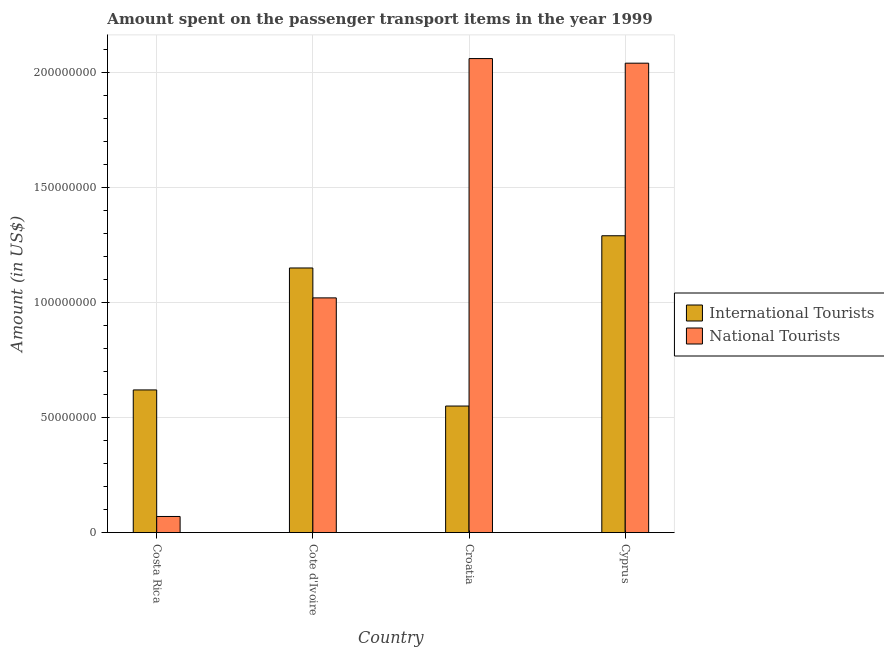How many bars are there on the 1st tick from the left?
Offer a terse response. 2. How many bars are there on the 2nd tick from the right?
Your answer should be very brief. 2. What is the label of the 2nd group of bars from the left?
Provide a short and direct response. Cote d'Ivoire. What is the amount spent on transport items of international tourists in Croatia?
Offer a terse response. 5.50e+07. Across all countries, what is the maximum amount spent on transport items of national tourists?
Your response must be concise. 2.06e+08. Across all countries, what is the minimum amount spent on transport items of national tourists?
Give a very brief answer. 7.00e+06. In which country was the amount spent on transport items of national tourists maximum?
Your answer should be compact. Croatia. In which country was the amount spent on transport items of national tourists minimum?
Your answer should be compact. Costa Rica. What is the total amount spent on transport items of national tourists in the graph?
Offer a terse response. 5.19e+08. What is the difference between the amount spent on transport items of international tourists in Cote d'Ivoire and that in Croatia?
Your answer should be very brief. 6.00e+07. What is the difference between the amount spent on transport items of national tourists in Costa Rica and the amount spent on transport items of international tourists in Cote d'Ivoire?
Provide a succinct answer. -1.08e+08. What is the average amount spent on transport items of international tourists per country?
Make the answer very short. 9.02e+07. What is the difference between the amount spent on transport items of international tourists and amount spent on transport items of national tourists in Cote d'Ivoire?
Make the answer very short. 1.30e+07. What is the ratio of the amount spent on transport items of national tourists in Costa Rica to that in Cyprus?
Offer a very short reply. 0.03. Is the difference between the amount spent on transport items of international tourists in Croatia and Cyprus greater than the difference between the amount spent on transport items of national tourists in Croatia and Cyprus?
Your response must be concise. No. What is the difference between the highest and the second highest amount spent on transport items of international tourists?
Your answer should be compact. 1.40e+07. What is the difference between the highest and the lowest amount spent on transport items of international tourists?
Give a very brief answer. 7.40e+07. In how many countries, is the amount spent on transport items of national tourists greater than the average amount spent on transport items of national tourists taken over all countries?
Your answer should be compact. 2. Is the sum of the amount spent on transport items of national tourists in Costa Rica and Croatia greater than the maximum amount spent on transport items of international tourists across all countries?
Offer a terse response. Yes. What does the 1st bar from the left in Croatia represents?
Your answer should be compact. International Tourists. What does the 1st bar from the right in Cote d'Ivoire represents?
Offer a very short reply. National Tourists. Are all the bars in the graph horizontal?
Give a very brief answer. No. What is the difference between two consecutive major ticks on the Y-axis?
Offer a terse response. 5.00e+07. Are the values on the major ticks of Y-axis written in scientific E-notation?
Make the answer very short. No. What is the title of the graph?
Your answer should be compact. Amount spent on the passenger transport items in the year 1999. What is the Amount (in US$) in International Tourists in Costa Rica?
Offer a very short reply. 6.20e+07. What is the Amount (in US$) of National Tourists in Costa Rica?
Your response must be concise. 7.00e+06. What is the Amount (in US$) in International Tourists in Cote d'Ivoire?
Make the answer very short. 1.15e+08. What is the Amount (in US$) of National Tourists in Cote d'Ivoire?
Offer a very short reply. 1.02e+08. What is the Amount (in US$) of International Tourists in Croatia?
Provide a succinct answer. 5.50e+07. What is the Amount (in US$) in National Tourists in Croatia?
Give a very brief answer. 2.06e+08. What is the Amount (in US$) in International Tourists in Cyprus?
Provide a short and direct response. 1.29e+08. What is the Amount (in US$) of National Tourists in Cyprus?
Your answer should be compact. 2.04e+08. Across all countries, what is the maximum Amount (in US$) in International Tourists?
Your answer should be compact. 1.29e+08. Across all countries, what is the maximum Amount (in US$) in National Tourists?
Give a very brief answer. 2.06e+08. Across all countries, what is the minimum Amount (in US$) of International Tourists?
Keep it short and to the point. 5.50e+07. What is the total Amount (in US$) in International Tourists in the graph?
Offer a terse response. 3.61e+08. What is the total Amount (in US$) in National Tourists in the graph?
Give a very brief answer. 5.19e+08. What is the difference between the Amount (in US$) in International Tourists in Costa Rica and that in Cote d'Ivoire?
Offer a terse response. -5.30e+07. What is the difference between the Amount (in US$) of National Tourists in Costa Rica and that in Cote d'Ivoire?
Your response must be concise. -9.50e+07. What is the difference between the Amount (in US$) of International Tourists in Costa Rica and that in Croatia?
Ensure brevity in your answer.  7.00e+06. What is the difference between the Amount (in US$) in National Tourists in Costa Rica and that in Croatia?
Make the answer very short. -1.99e+08. What is the difference between the Amount (in US$) of International Tourists in Costa Rica and that in Cyprus?
Provide a short and direct response. -6.70e+07. What is the difference between the Amount (in US$) of National Tourists in Costa Rica and that in Cyprus?
Give a very brief answer. -1.97e+08. What is the difference between the Amount (in US$) in International Tourists in Cote d'Ivoire and that in Croatia?
Ensure brevity in your answer.  6.00e+07. What is the difference between the Amount (in US$) of National Tourists in Cote d'Ivoire and that in Croatia?
Give a very brief answer. -1.04e+08. What is the difference between the Amount (in US$) of International Tourists in Cote d'Ivoire and that in Cyprus?
Provide a succinct answer. -1.40e+07. What is the difference between the Amount (in US$) of National Tourists in Cote d'Ivoire and that in Cyprus?
Keep it short and to the point. -1.02e+08. What is the difference between the Amount (in US$) in International Tourists in Croatia and that in Cyprus?
Provide a succinct answer. -7.40e+07. What is the difference between the Amount (in US$) in International Tourists in Costa Rica and the Amount (in US$) in National Tourists in Cote d'Ivoire?
Provide a succinct answer. -4.00e+07. What is the difference between the Amount (in US$) of International Tourists in Costa Rica and the Amount (in US$) of National Tourists in Croatia?
Offer a terse response. -1.44e+08. What is the difference between the Amount (in US$) of International Tourists in Costa Rica and the Amount (in US$) of National Tourists in Cyprus?
Your response must be concise. -1.42e+08. What is the difference between the Amount (in US$) of International Tourists in Cote d'Ivoire and the Amount (in US$) of National Tourists in Croatia?
Your response must be concise. -9.10e+07. What is the difference between the Amount (in US$) in International Tourists in Cote d'Ivoire and the Amount (in US$) in National Tourists in Cyprus?
Make the answer very short. -8.90e+07. What is the difference between the Amount (in US$) of International Tourists in Croatia and the Amount (in US$) of National Tourists in Cyprus?
Give a very brief answer. -1.49e+08. What is the average Amount (in US$) in International Tourists per country?
Keep it short and to the point. 9.02e+07. What is the average Amount (in US$) of National Tourists per country?
Ensure brevity in your answer.  1.30e+08. What is the difference between the Amount (in US$) in International Tourists and Amount (in US$) in National Tourists in Costa Rica?
Your answer should be compact. 5.50e+07. What is the difference between the Amount (in US$) in International Tourists and Amount (in US$) in National Tourists in Cote d'Ivoire?
Keep it short and to the point. 1.30e+07. What is the difference between the Amount (in US$) in International Tourists and Amount (in US$) in National Tourists in Croatia?
Offer a very short reply. -1.51e+08. What is the difference between the Amount (in US$) in International Tourists and Amount (in US$) in National Tourists in Cyprus?
Give a very brief answer. -7.50e+07. What is the ratio of the Amount (in US$) in International Tourists in Costa Rica to that in Cote d'Ivoire?
Your answer should be compact. 0.54. What is the ratio of the Amount (in US$) of National Tourists in Costa Rica to that in Cote d'Ivoire?
Provide a succinct answer. 0.07. What is the ratio of the Amount (in US$) of International Tourists in Costa Rica to that in Croatia?
Your answer should be very brief. 1.13. What is the ratio of the Amount (in US$) in National Tourists in Costa Rica to that in Croatia?
Offer a terse response. 0.03. What is the ratio of the Amount (in US$) of International Tourists in Costa Rica to that in Cyprus?
Your answer should be very brief. 0.48. What is the ratio of the Amount (in US$) of National Tourists in Costa Rica to that in Cyprus?
Your response must be concise. 0.03. What is the ratio of the Amount (in US$) in International Tourists in Cote d'Ivoire to that in Croatia?
Your answer should be compact. 2.09. What is the ratio of the Amount (in US$) in National Tourists in Cote d'Ivoire to that in Croatia?
Offer a terse response. 0.5. What is the ratio of the Amount (in US$) of International Tourists in Cote d'Ivoire to that in Cyprus?
Your answer should be very brief. 0.89. What is the ratio of the Amount (in US$) of National Tourists in Cote d'Ivoire to that in Cyprus?
Keep it short and to the point. 0.5. What is the ratio of the Amount (in US$) in International Tourists in Croatia to that in Cyprus?
Make the answer very short. 0.43. What is the ratio of the Amount (in US$) in National Tourists in Croatia to that in Cyprus?
Your response must be concise. 1.01. What is the difference between the highest and the second highest Amount (in US$) in International Tourists?
Ensure brevity in your answer.  1.40e+07. What is the difference between the highest and the lowest Amount (in US$) of International Tourists?
Provide a succinct answer. 7.40e+07. What is the difference between the highest and the lowest Amount (in US$) in National Tourists?
Make the answer very short. 1.99e+08. 